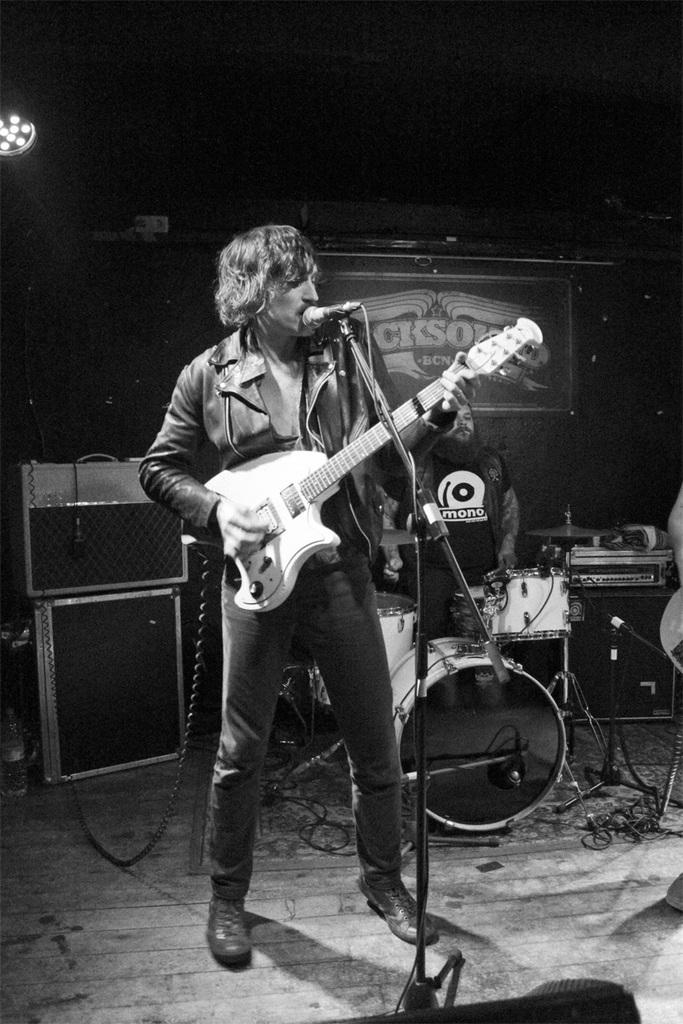What is the person in the image wearing? The person is wearing a black coat in the image. What activity is the person in the black coat engaged in? The person is playing a guitar and singing. What object is in front of the person playing the guitar? There is a microphone in front of the person. Can you describe the other person in the image? The other person in the background is playing drums. How many children are present in the image? There is no mention of children in the image; it features a person playing a guitar and singing, a microphone, and another person playing drums. 